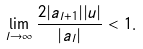<formula> <loc_0><loc_0><loc_500><loc_500>\lim _ { l \rightarrow \infty } \frac { 2 | a _ { l + 1 } | | u | } { | a _ { l } | } < 1 .</formula> 